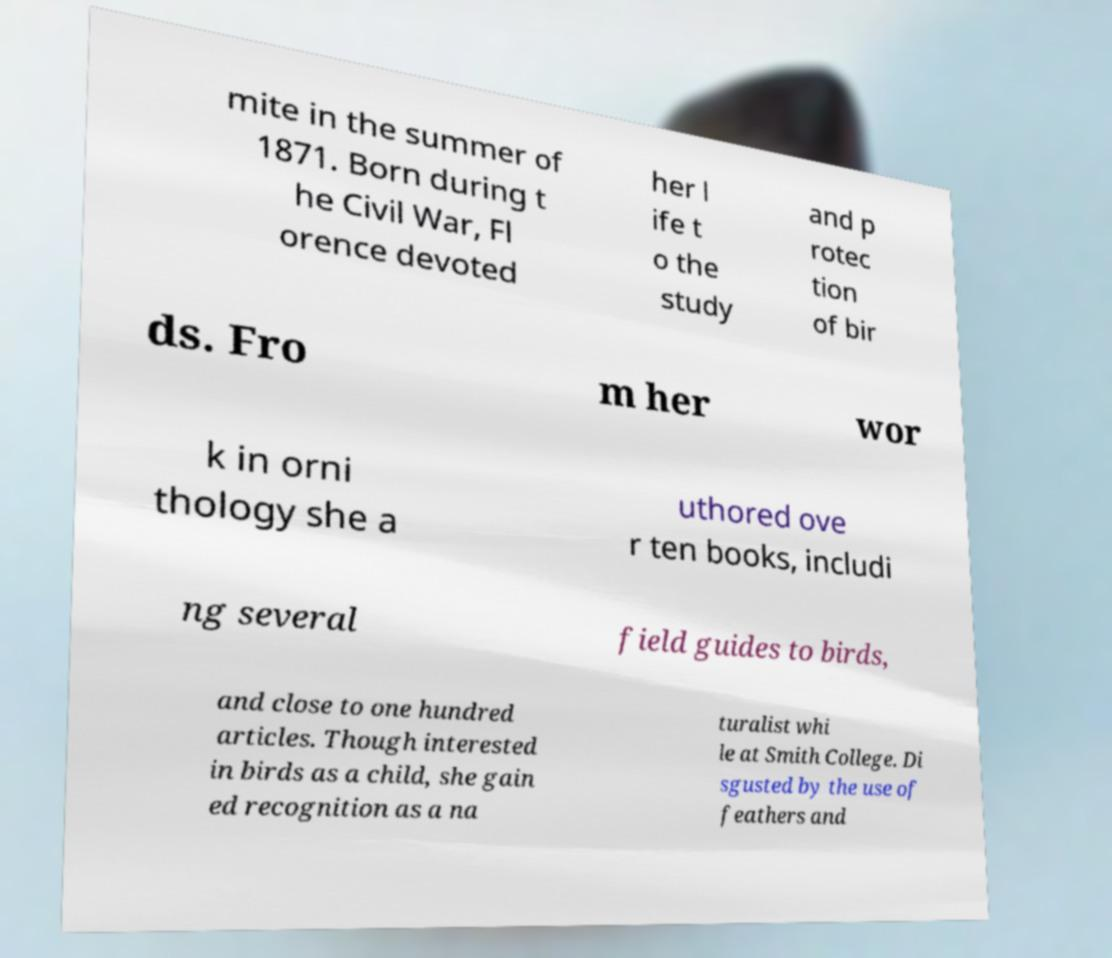What messages or text are displayed in this image? I need them in a readable, typed format. mite in the summer of 1871. Born during t he Civil War, Fl orence devoted her l ife t o the study and p rotec tion of bir ds. Fro m her wor k in orni thology she a uthored ove r ten books, includi ng several field guides to birds, and close to one hundred articles. Though interested in birds as a child, she gain ed recognition as a na turalist whi le at Smith College. Di sgusted by the use of feathers and 